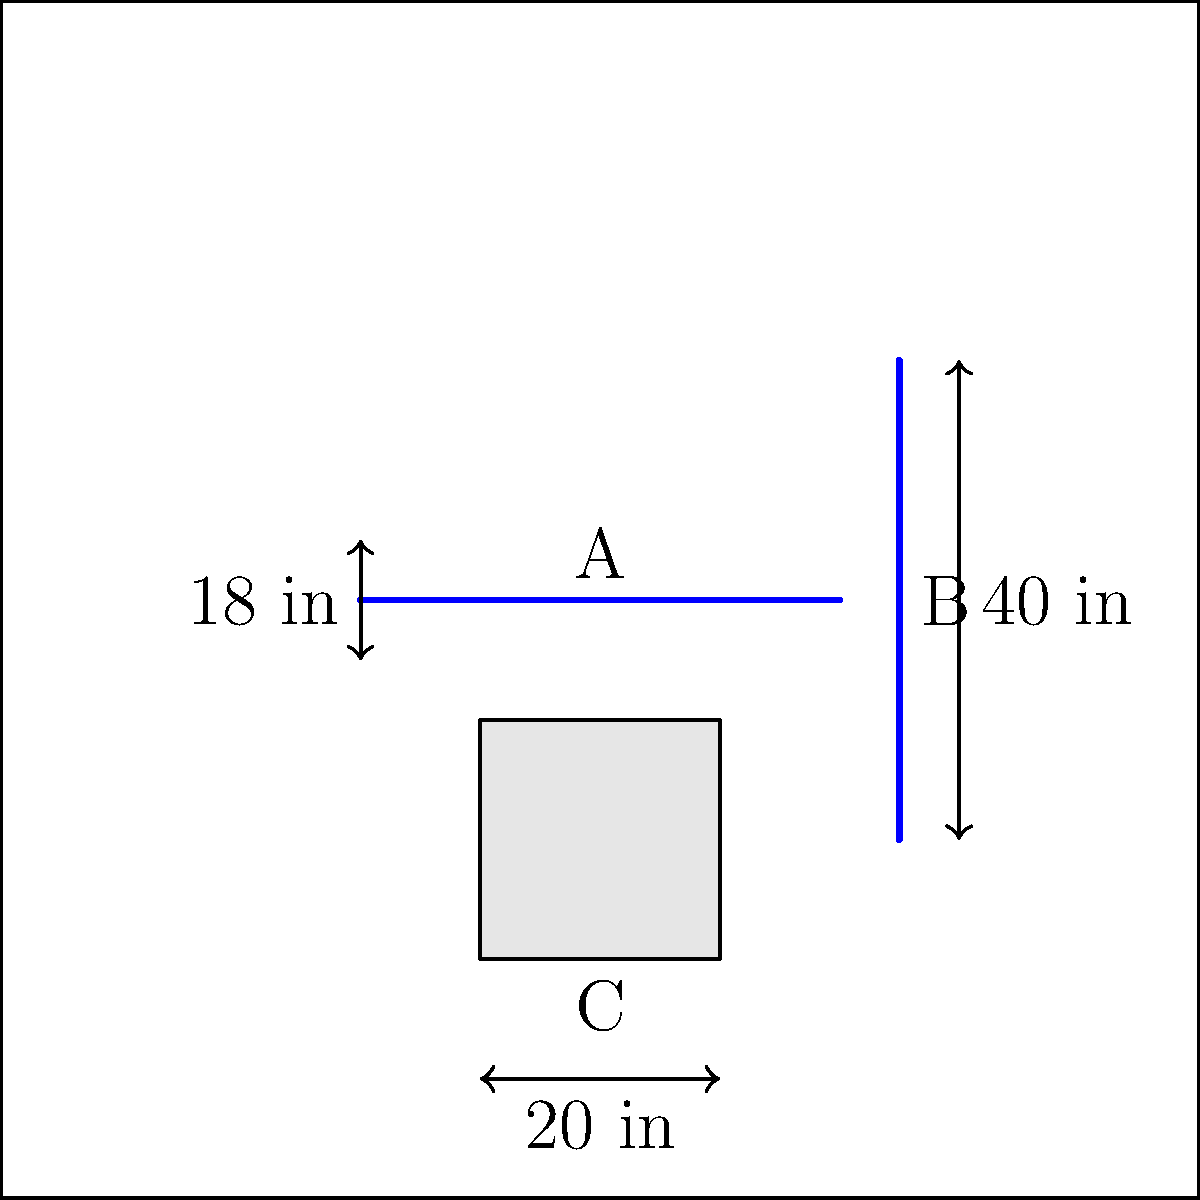In the schematic of a senior-friendly bathroom, what is the recommended height (C) for the toilet seat, and what are the ideal placements for the grab bars (A and B) to ensure maximum safety and comfort for elderly residents? To determine the recommended height for the toilet seat and ideal placements for grab bars in a senior-friendly bathroom, we need to consider the following steps:

1. Toilet seat height (C):
   - The Americans with Disabilities Act (ADA) recommends a toilet seat height between 17 to 19 inches from the floor for seniors and individuals with mobility issues.
   - This height range allows for easier transfers from wheelchairs and reduces strain when sitting down or standing up.

2. Horizontal grab bar placement (A):
   - The horizontal grab bar should be placed on the side wall closest to the toilet.
   - ADA guidelines recommend installing it 33 to 36 inches above the floor.
   - The bar should extend at least 54 inches from the rear wall and be 1.25 to 1.5 inches in diameter.

3. Vertical grab bar placement (B):
   - A vertical grab bar should be installed on the side wall closest to the toilet.
   - It should be 18 inches long and positioned 39 to 41 inches from the rear wall.
   - The bottom of the vertical bar should be 39 to 41 inches above the floor.

4. Distance between grab bars:
   - The space between the grab bars should be at least 36 inches to accommodate various body sizes and allow for easy maneuvering.

5. Grab bar strength:
   - All grab bars must be able to withstand at least 250 pounds of force in any direction.

By following these guidelines, you can ensure maximum safety and comfort for elderly residents using the bathroom facilities.
Answer: C: 17-19 inches; A: 33-36 inches above floor, 54 inches from rear wall; B: 39-41 inches from rear wall, bottom 39-41 inches above floor 